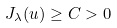Convert formula to latex. <formula><loc_0><loc_0><loc_500><loc_500>J _ { \lambda } ( u ) \geq C > 0</formula> 